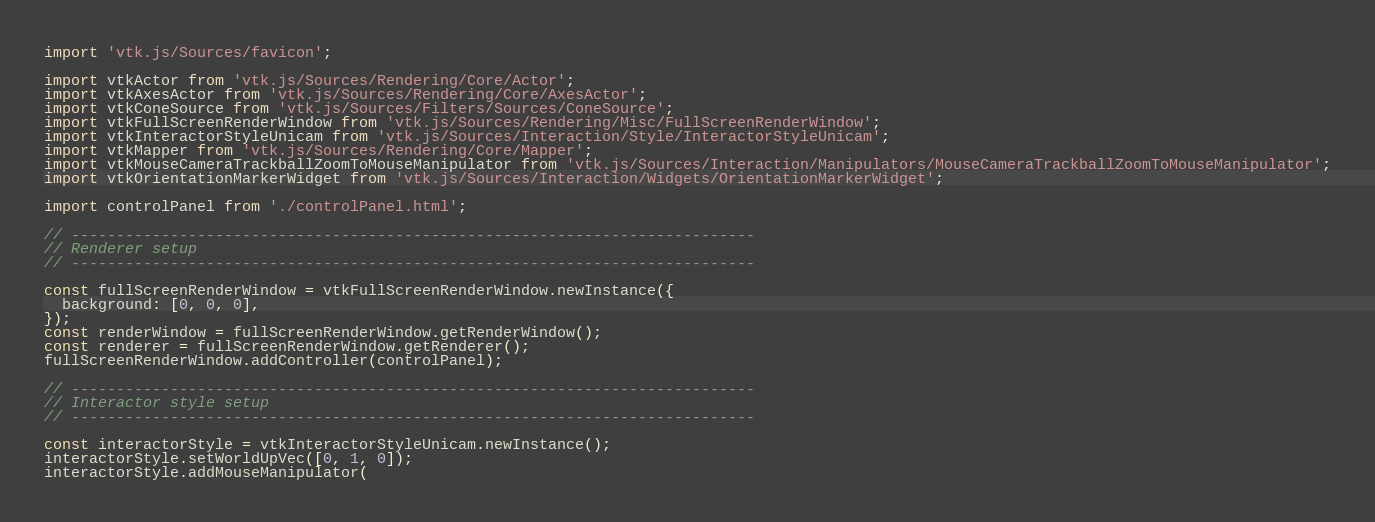<code> <loc_0><loc_0><loc_500><loc_500><_JavaScript_>import 'vtk.js/Sources/favicon';

import vtkActor from 'vtk.js/Sources/Rendering/Core/Actor';
import vtkAxesActor from 'vtk.js/Sources/Rendering/Core/AxesActor';
import vtkConeSource from 'vtk.js/Sources/Filters/Sources/ConeSource';
import vtkFullScreenRenderWindow from 'vtk.js/Sources/Rendering/Misc/FullScreenRenderWindow';
import vtkInteractorStyleUnicam from 'vtk.js/Sources/Interaction/Style/InteractorStyleUnicam';
import vtkMapper from 'vtk.js/Sources/Rendering/Core/Mapper';
import vtkMouseCameraTrackballZoomToMouseManipulator from 'vtk.js/Sources/Interaction/Manipulators/MouseCameraTrackballZoomToMouseManipulator';
import vtkOrientationMarkerWidget from 'vtk.js/Sources/Interaction/Widgets/OrientationMarkerWidget';

import controlPanel from './controlPanel.html';

// ----------------------------------------------------------------------------
// Renderer setup
// ----------------------------------------------------------------------------

const fullScreenRenderWindow = vtkFullScreenRenderWindow.newInstance({
  background: [0, 0, 0],
});
const renderWindow = fullScreenRenderWindow.getRenderWindow();
const renderer = fullScreenRenderWindow.getRenderer();
fullScreenRenderWindow.addController(controlPanel);

// ----------------------------------------------------------------------------
// Interactor style setup
// ----------------------------------------------------------------------------

const interactorStyle = vtkInteractorStyleUnicam.newInstance();
interactorStyle.setWorldUpVec([0, 1, 0]);
interactorStyle.addMouseManipulator(</code> 